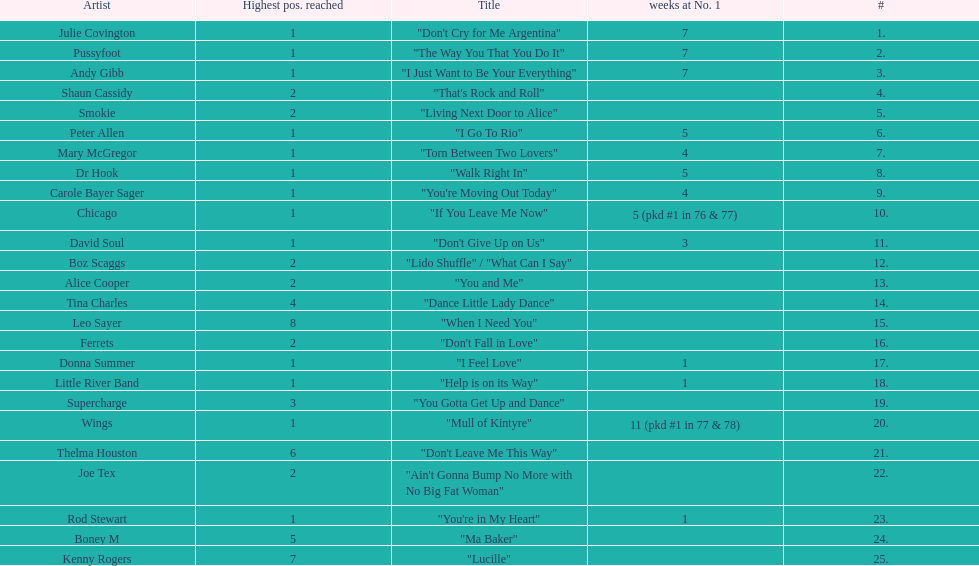Which song stayed at no.1 for the most amount of weeks. "Mull of Kintyre". 